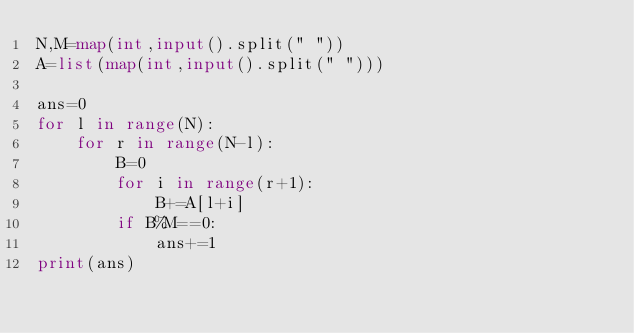Convert code to text. <code><loc_0><loc_0><loc_500><loc_500><_Python_>N,M=map(int,input().split(" "))
A=list(map(int,input().split(" ")))

ans=0
for l in range(N):
    for r in range(N-l):
        B=0
        for i in range(r+1):
            B+=A[l+i]
        if B%M==0:
            ans+=1
print(ans)</code> 